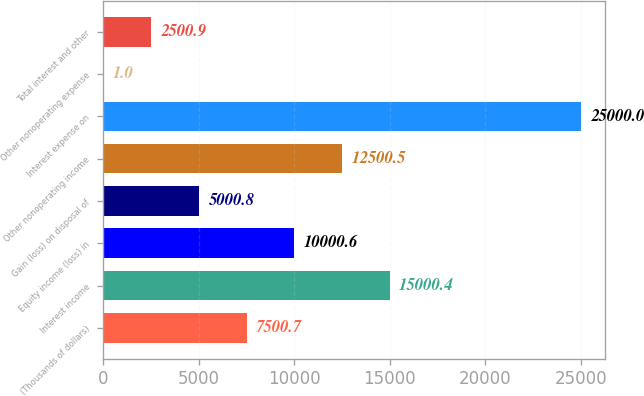<chart> <loc_0><loc_0><loc_500><loc_500><bar_chart><fcel>(Thousands of dollars)<fcel>Interest income<fcel>Equity income (loss) in<fcel>Gain (loss) on disposal of<fcel>Other nonoperating income<fcel>Interest expense on<fcel>Other nonoperating expense<fcel>Total interest and other<nl><fcel>7500.7<fcel>15000.4<fcel>10000.6<fcel>5000.8<fcel>12500.5<fcel>25000<fcel>1<fcel>2500.9<nl></chart> 